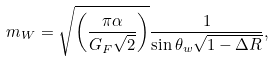Convert formula to latex. <formula><loc_0><loc_0><loc_500><loc_500>m _ { W } = \sqrt { \left ( \frac { \pi \alpha } { G _ { F } \sqrt { 2 } } \right ) } \frac { 1 } { \sin \theta _ { w } \sqrt { 1 - \Delta R } } ,</formula> 